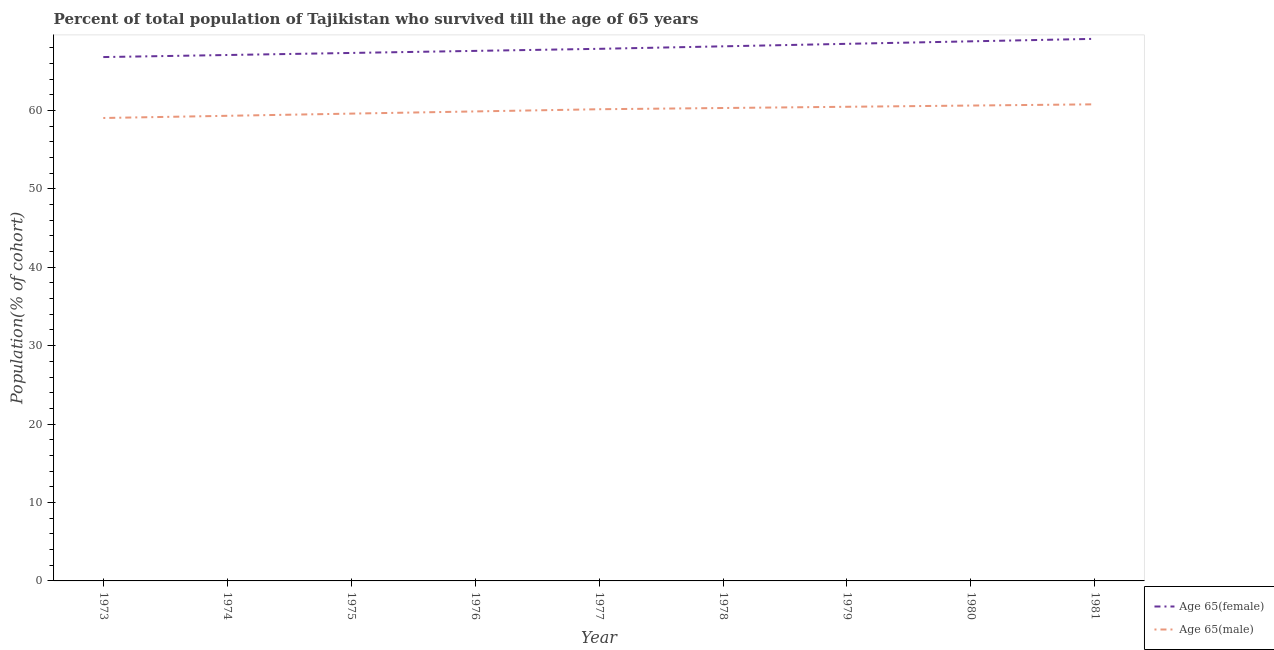Does the line corresponding to percentage of female population who survived till age of 65 intersect with the line corresponding to percentage of male population who survived till age of 65?
Offer a very short reply. No. Is the number of lines equal to the number of legend labels?
Keep it short and to the point. Yes. What is the percentage of male population who survived till age of 65 in 1974?
Provide a short and direct response. 59.31. Across all years, what is the maximum percentage of female population who survived till age of 65?
Your answer should be very brief. 69.12. Across all years, what is the minimum percentage of male population who survived till age of 65?
Provide a short and direct response. 59.03. What is the total percentage of female population who survived till age of 65 in the graph?
Provide a short and direct response. 611.19. What is the difference between the percentage of male population who survived till age of 65 in 1975 and that in 1976?
Your response must be concise. -0.28. What is the difference between the percentage of male population who survived till age of 65 in 1974 and the percentage of female population who survived till age of 65 in 1976?
Offer a very short reply. -8.28. What is the average percentage of male population who survived till age of 65 per year?
Ensure brevity in your answer.  60.01. In the year 1980, what is the difference between the percentage of female population who survived till age of 65 and percentage of male population who survived till age of 65?
Provide a short and direct response. 8.19. In how many years, is the percentage of male population who survived till age of 65 greater than 14 %?
Give a very brief answer. 9. What is the ratio of the percentage of female population who survived till age of 65 in 1976 to that in 1977?
Keep it short and to the point. 1. Is the percentage of female population who survived till age of 65 in 1978 less than that in 1981?
Ensure brevity in your answer.  Yes. Is the difference between the percentage of female population who survived till age of 65 in 1974 and 1979 greater than the difference between the percentage of male population who survived till age of 65 in 1974 and 1979?
Make the answer very short. No. What is the difference between the highest and the second highest percentage of male population who survived till age of 65?
Keep it short and to the point. 0.16. What is the difference between the highest and the lowest percentage of female population who survived till age of 65?
Your response must be concise. 2.32. In how many years, is the percentage of female population who survived till age of 65 greater than the average percentage of female population who survived till age of 65 taken over all years?
Provide a short and direct response. 4. Does the percentage of female population who survived till age of 65 monotonically increase over the years?
Make the answer very short. Yes. Is the percentage of male population who survived till age of 65 strictly greater than the percentage of female population who survived till age of 65 over the years?
Give a very brief answer. No. Is the percentage of male population who survived till age of 65 strictly less than the percentage of female population who survived till age of 65 over the years?
Provide a succinct answer. Yes. How many lines are there?
Provide a succinct answer. 2. What is the difference between two consecutive major ticks on the Y-axis?
Provide a short and direct response. 10. Are the values on the major ticks of Y-axis written in scientific E-notation?
Keep it short and to the point. No. Does the graph contain any zero values?
Offer a terse response. No. How many legend labels are there?
Ensure brevity in your answer.  2. How are the legend labels stacked?
Give a very brief answer. Vertical. What is the title of the graph?
Your response must be concise. Percent of total population of Tajikistan who survived till the age of 65 years. Does "Electricity and heat production" appear as one of the legend labels in the graph?
Offer a very short reply. No. What is the label or title of the Y-axis?
Offer a terse response. Population(% of cohort). What is the Population(% of cohort) in Age 65(female) in 1973?
Offer a very short reply. 66.8. What is the Population(% of cohort) in Age 65(male) in 1973?
Give a very brief answer. 59.03. What is the Population(% of cohort) of Age 65(female) in 1974?
Make the answer very short. 67.06. What is the Population(% of cohort) in Age 65(male) in 1974?
Ensure brevity in your answer.  59.31. What is the Population(% of cohort) of Age 65(female) in 1975?
Keep it short and to the point. 67.32. What is the Population(% of cohort) of Age 65(male) in 1975?
Provide a succinct answer. 59.59. What is the Population(% of cohort) of Age 65(female) in 1976?
Ensure brevity in your answer.  67.59. What is the Population(% of cohort) of Age 65(male) in 1976?
Your response must be concise. 59.87. What is the Population(% of cohort) in Age 65(female) in 1977?
Ensure brevity in your answer.  67.85. What is the Population(% of cohort) of Age 65(male) in 1977?
Offer a terse response. 60.15. What is the Population(% of cohort) of Age 65(female) in 1978?
Your response must be concise. 68.17. What is the Population(% of cohort) in Age 65(male) in 1978?
Provide a succinct answer. 60.3. What is the Population(% of cohort) in Age 65(female) in 1979?
Provide a succinct answer. 68.49. What is the Population(% of cohort) in Age 65(male) in 1979?
Make the answer very short. 60.46. What is the Population(% of cohort) in Age 65(female) in 1980?
Offer a terse response. 68.8. What is the Population(% of cohort) in Age 65(male) in 1980?
Give a very brief answer. 60.62. What is the Population(% of cohort) in Age 65(female) in 1981?
Your response must be concise. 69.12. What is the Population(% of cohort) in Age 65(male) in 1981?
Offer a very short reply. 60.77. Across all years, what is the maximum Population(% of cohort) of Age 65(female)?
Keep it short and to the point. 69.12. Across all years, what is the maximum Population(% of cohort) of Age 65(male)?
Provide a short and direct response. 60.77. Across all years, what is the minimum Population(% of cohort) of Age 65(female)?
Offer a very short reply. 66.8. Across all years, what is the minimum Population(% of cohort) in Age 65(male)?
Give a very brief answer. 59.03. What is the total Population(% of cohort) in Age 65(female) in the graph?
Offer a very short reply. 611.19. What is the total Population(% of cohort) of Age 65(male) in the graph?
Offer a terse response. 540.08. What is the difference between the Population(% of cohort) of Age 65(female) in 1973 and that in 1974?
Your response must be concise. -0.26. What is the difference between the Population(% of cohort) in Age 65(male) in 1973 and that in 1974?
Your answer should be very brief. -0.28. What is the difference between the Population(% of cohort) in Age 65(female) in 1973 and that in 1975?
Your response must be concise. -0.53. What is the difference between the Population(% of cohort) of Age 65(male) in 1973 and that in 1975?
Your answer should be compact. -0.56. What is the difference between the Population(% of cohort) in Age 65(female) in 1973 and that in 1976?
Your answer should be compact. -0.79. What is the difference between the Population(% of cohort) of Age 65(male) in 1973 and that in 1976?
Offer a terse response. -0.84. What is the difference between the Population(% of cohort) of Age 65(female) in 1973 and that in 1977?
Provide a succinct answer. -1.05. What is the difference between the Population(% of cohort) in Age 65(male) in 1973 and that in 1977?
Ensure brevity in your answer.  -1.12. What is the difference between the Population(% of cohort) in Age 65(female) in 1973 and that in 1978?
Provide a short and direct response. -1.37. What is the difference between the Population(% of cohort) of Age 65(male) in 1973 and that in 1978?
Your answer should be very brief. -1.27. What is the difference between the Population(% of cohort) in Age 65(female) in 1973 and that in 1979?
Provide a short and direct response. -1.69. What is the difference between the Population(% of cohort) of Age 65(male) in 1973 and that in 1979?
Your answer should be compact. -1.43. What is the difference between the Population(% of cohort) of Age 65(female) in 1973 and that in 1980?
Offer a very short reply. -2.01. What is the difference between the Population(% of cohort) in Age 65(male) in 1973 and that in 1980?
Offer a very short reply. -1.59. What is the difference between the Population(% of cohort) of Age 65(female) in 1973 and that in 1981?
Give a very brief answer. -2.32. What is the difference between the Population(% of cohort) in Age 65(male) in 1973 and that in 1981?
Provide a short and direct response. -1.74. What is the difference between the Population(% of cohort) in Age 65(female) in 1974 and that in 1975?
Give a very brief answer. -0.26. What is the difference between the Population(% of cohort) of Age 65(male) in 1974 and that in 1975?
Provide a short and direct response. -0.28. What is the difference between the Population(% of cohort) of Age 65(female) in 1974 and that in 1976?
Your response must be concise. -0.53. What is the difference between the Population(% of cohort) in Age 65(male) in 1974 and that in 1976?
Offer a very short reply. -0.56. What is the difference between the Population(% of cohort) of Age 65(female) in 1974 and that in 1977?
Keep it short and to the point. -0.79. What is the difference between the Population(% of cohort) in Age 65(male) in 1974 and that in 1977?
Your response must be concise. -0.84. What is the difference between the Population(% of cohort) of Age 65(female) in 1974 and that in 1978?
Provide a succinct answer. -1.11. What is the difference between the Population(% of cohort) of Age 65(male) in 1974 and that in 1978?
Your answer should be compact. -0.99. What is the difference between the Population(% of cohort) of Age 65(female) in 1974 and that in 1979?
Your answer should be very brief. -1.43. What is the difference between the Population(% of cohort) of Age 65(male) in 1974 and that in 1979?
Your answer should be compact. -1.15. What is the difference between the Population(% of cohort) in Age 65(female) in 1974 and that in 1980?
Provide a short and direct response. -1.74. What is the difference between the Population(% of cohort) in Age 65(male) in 1974 and that in 1980?
Provide a short and direct response. -1.31. What is the difference between the Population(% of cohort) of Age 65(female) in 1974 and that in 1981?
Offer a very short reply. -2.06. What is the difference between the Population(% of cohort) in Age 65(male) in 1974 and that in 1981?
Your response must be concise. -1.46. What is the difference between the Population(% of cohort) of Age 65(female) in 1975 and that in 1976?
Offer a terse response. -0.26. What is the difference between the Population(% of cohort) of Age 65(male) in 1975 and that in 1976?
Your response must be concise. -0.28. What is the difference between the Population(% of cohort) in Age 65(female) in 1975 and that in 1977?
Provide a short and direct response. -0.53. What is the difference between the Population(% of cohort) of Age 65(male) in 1975 and that in 1977?
Your answer should be very brief. -0.56. What is the difference between the Population(% of cohort) in Age 65(female) in 1975 and that in 1978?
Your response must be concise. -0.84. What is the difference between the Population(% of cohort) in Age 65(male) in 1975 and that in 1978?
Make the answer very short. -0.71. What is the difference between the Population(% of cohort) in Age 65(female) in 1975 and that in 1979?
Provide a short and direct response. -1.16. What is the difference between the Population(% of cohort) in Age 65(male) in 1975 and that in 1979?
Offer a terse response. -0.87. What is the difference between the Population(% of cohort) of Age 65(female) in 1975 and that in 1980?
Provide a short and direct response. -1.48. What is the difference between the Population(% of cohort) in Age 65(male) in 1975 and that in 1980?
Ensure brevity in your answer.  -1.03. What is the difference between the Population(% of cohort) in Age 65(female) in 1975 and that in 1981?
Provide a succinct answer. -1.8. What is the difference between the Population(% of cohort) in Age 65(male) in 1975 and that in 1981?
Provide a short and direct response. -1.19. What is the difference between the Population(% of cohort) of Age 65(female) in 1976 and that in 1977?
Make the answer very short. -0.26. What is the difference between the Population(% of cohort) in Age 65(male) in 1976 and that in 1977?
Your answer should be compact. -0.28. What is the difference between the Population(% of cohort) in Age 65(female) in 1976 and that in 1978?
Make the answer very short. -0.58. What is the difference between the Population(% of cohort) of Age 65(male) in 1976 and that in 1978?
Ensure brevity in your answer.  -0.44. What is the difference between the Population(% of cohort) of Age 65(female) in 1976 and that in 1979?
Provide a short and direct response. -0.9. What is the difference between the Population(% of cohort) in Age 65(male) in 1976 and that in 1979?
Ensure brevity in your answer.  -0.59. What is the difference between the Population(% of cohort) of Age 65(female) in 1976 and that in 1980?
Offer a very short reply. -1.22. What is the difference between the Population(% of cohort) in Age 65(male) in 1976 and that in 1980?
Make the answer very short. -0.75. What is the difference between the Population(% of cohort) of Age 65(female) in 1976 and that in 1981?
Provide a short and direct response. -1.54. What is the difference between the Population(% of cohort) in Age 65(male) in 1976 and that in 1981?
Offer a terse response. -0.91. What is the difference between the Population(% of cohort) of Age 65(female) in 1977 and that in 1978?
Your answer should be very brief. -0.32. What is the difference between the Population(% of cohort) in Age 65(male) in 1977 and that in 1978?
Make the answer very short. -0.16. What is the difference between the Population(% of cohort) in Age 65(female) in 1977 and that in 1979?
Your answer should be very brief. -0.64. What is the difference between the Population(% of cohort) of Age 65(male) in 1977 and that in 1979?
Provide a short and direct response. -0.31. What is the difference between the Population(% of cohort) in Age 65(female) in 1977 and that in 1980?
Give a very brief answer. -0.96. What is the difference between the Population(% of cohort) in Age 65(male) in 1977 and that in 1980?
Provide a short and direct response. -0.47. What is the difference between the Population(% of cohort) of Age 65(female) in 1977 and that in 1981?
Ensure brevity in your answer.  -1.27. What is the difference between the Population(% of cohort) in Age 65(male) in 1977 and that in 1981?
Make the answer very short. -0.63. What is the difference between the Population(% of cohort) in Age 65(female) in 1978 and that in 1979?
Keep it short and to the point. -0.32. What is the difference between the Population(% of cohort) in Age 65(male) in 1978 and that in 1979?
Provide a succinct answer. -0.16. What is the difference between the Population(% of cohort) in Age 65(female) in 1978 and that in 1980?
Provide a succinct answer. -0.64. What is the difference between the Population(% of cohort) of Age 65(male) in 1978 and that in 1980?
Offer a terse response. -0.31. What is the difference between the Population(% of cohort) in Age 65(female) in 1978 and that in 1981?
Provide a short and direct response. -0.96. What is the difference between the Population(% of cohort) of Age 65(male) in 1978 and that in 1981?
Offer a very short reply. -0.47. What is the difference between the Population(% of cohort) in Age 65(female) in 1979 and that in 1980?
Provide a short and direct response. -0.32. What is the difference between the Population(% of cohort) of Age 65(male) in 1979 and that in 1980?
Provide a succinct answer. -0.16. What is the difference between the Population(% of cohort) of Age 65(female) in 1979 and that in 1981?
Your answer should be compact. -0.64. What is the difference between the Population(% of cohort) in Age 65(male) in 1979 and that in 1981?
Your answer should be compact. -0.31. What is the difference between the Population(% of cohort) of Age 65(female) in 1980 and that in 1981?
Provide a succinct answer. -0.32. What is the difference between the Population(% of cohort) of Age 65(male) in 1980 and that in 1981?
Make the answer very short. -0.16. What is the difference between the Population(% of cohort) of Age 65(female) in 1973 and the Population(% of cohort) of Age 65(male) in 1974?
Offer a very short reply. 7.49. What is the difference between the Population(% of cohort) of Age 65(female) in 1973 and the Population(% of cohort) of Age 65(male) in 1975?
Offer a terse response. 7.21. What is the difference between the Population(% of cohort) in Age 65(female) in 1973 and the Population(% of cohort) in Age 65(male) in 1976?
Make the answer very short. 6.93. What is the difference between the Population(% of cohort) of Age 65(female) in 1973 and the Population(% of cohort) of Age 65(male) in 1977?
Your response must be concise. 6.65. What is the difference between the Population(% of cohort) in Age 65(female) in 1973 and the Population(% of cohort) in Age 65(male) in 1978?
Your answer should be very brief. 6.5. What is the difference between the Population(% of cohort) in Age 65(female) in 1973 and the Population(% of cohort) in Age 65(male) in 1979?
Offer a very short reply. 6.34. What is the difference between the Population(% of cohort) of Age 65(female) in 1973 and the Population(% of cohort) of Age 65(male) in 1980?
Ensure brevity in your answer.  6.18. What is the difference between the Population(% of cohort) of Age 65(female) in 1973 and the Population(% of cohort) of Age 65(male) in 1981?
Give a very brief answer. 6.03. What is the difference between the Population(% of cohort) in Age 65(female) in 1974 and the Population(% of cohort) in Age 65(male) in 1975?
Offer a very short reply. 7.47. What is the difference between the Population(% of cohort) of Age 65(female) in 1974 and the Population(% of cohort) of Age 65(male) in 1976?
Provide a succinct answer. 7.19. What is the difference between the Population(% of cohort) of Age 65(female) in 1974 and the Population(% of cohort) of Age 65(male) in 1977?
Ensure brevity in your answer.  6.92. What is the difference between the Population(% of cohort) in Age 65(female) in 1974 and the Population(% of cohort) in Age 65(male) in 1978?
Keep it short and to the point. 6.76. What is the difference between the Population(% of cohort) in Age 65(female) in 1974 and the Population(% of cohort) in Age 65(male) in 1979?
Offer a very short reply. 6.6. What is the difference between the Population(% of cohort) of Age 65(female) in 1974 and the Population(% of cohort) of Age 65(male) in 1980?
Provide a short and direct response. 6.45. What is the difference between the Population(% of cohort) of Age 65(female) in 1974 and the Population(% of cohort) of Age 65(male) in 1981?
Provide a short and direct response. 6.29. What is the difference between the Population(% of cohort) in Age 65(female) in 1975 and the Population(% of cohort) in Age 65(male) in 1976?
Your answer should be very brief. 7.46. What is the difference between the Population(% of cohort) in Age 65(female) in 1975 and the Population(% of cohort) in Age 65(male) in 1977?
Provide a short and direct response. 7.18. What is the difference between the Population(% of cohort) in Age 65(female) in 1975 and the Population(% of cohort) in Age 65(male) in 1978?
Keep it short and to the point. 7.02. What is the difference between the Population(% of cohort) of Age 65(female) in 1975 and the Population(% of cohort) of Age 65(male) in 1979?
Make the answer very short. 6.86. What is the difference between the Population(% of cohort) in Age 65(female) in 1975 and the Population(% of cohort) in Age 65(male) in 1980?
Give a very brief answer. 6.71. What is the difference between the Population(% of cohort) of Age 65(female) in 1975 and the Population(% of cohort) of Age 65(male) in 1981?
Your answer should be compact. 6.55. What is the difference between the Population(% of cohort) in Age 65(female) in 1976 and the Population(% of cohort) in Age 65(male) in 1977?
Ensure brevity in your answer.  7.44. What is the difference between the Population(% of cohort) of Age 65(female) in 1976 and the Population(% of cohort) of Age 65(male) in 1978?
Offer a terse response. 7.28. What is the difference between the Population(% of cohort) in Age 65(female) in 1976 and the Population(% of cohort) in Age 65(male) in 1979?
Your response must be concise. 7.13. What is the difference between the Population(% of cohort) in Age 65(female) in 1976 and the Population(% of cohort) in Age 65(male) in 1980?
Offer a very short reply. 6.97. What is the difference between the Population(% of cohort) of Age 65(female) in 1976 and the Population(% of cohort) of Age 65(male) in 1981?
Provide a short and direct response. 6.81. What is the difference between the Population(% of cohort) of Age 65(female) in 1977 and the Population(% of cohort) of Age 65(male) in 1978?
Your answer should be very brief. 7.55. What is the difference between the Population(% of cohort) in Age 65(female) in 1977 and the Population(% of cohort) in Age 65(male) in 1979?
Provide a short and direct response. 7.39. What is the difference between the Population(% of cohort) in Age 65(female) in 1977 and the Population(% of cohort) in Age 65(male) in 1980?
Your response must be concise. 7.23. What is the difference between the Population(% of cohort) of Age 65(female) in 1977 and the Population(% of cohort) of Age 65(male) in 1981?
Offer a very short reply. 7.08. What is the difference between the Population(% of cohort) of Age 65(female) in 1978 and the Population(% of cohort) of Age 65(male) in 1979?
Provide a short and direct response. 7.71. What is the difference between the Population(% of cohort) of Age 65(female) in 1978 and the Population(% of cohort) of Age 65(male) in 1980?
Make the answer very short. 7.55. What is the difference between the Population(% of cohort) of Age 65(female) in 1978 and the Population(% of cohort) of Age 65(male) in 1981?
Ensure brevity in your answer.  7.39. What is the difference between the Population(% of cohort) in Age 65(female) in 1979 and the Population(% of cohort) in Age 65(male) in 1980?
Provide a succinct answer. 7.87. What is the difference between the Population(% of cohort) in Age 65(female) in 1979 and the Population(% of cohort) in Age 65(male) in 1981?
Provide a succinct answer. 7.71. What is the difference between the Population(% of cohort) of Age 65(female) in 1980 and the Population(% of cohort) of Age 65(male) in 1981?
Make the answer very short. 8.03. What is the average Population(% of cohort) in Age 65(female) per year?
Provide a succinct answer. 67.91. What is the average Population(% of cohort) in Age 65(male) per year?
Give a very brief answer. 60.01. In the year 1973, what is the difference between the Population(% of cohort) of Age 65(female) and Population(% of cohort) of Age 65(male)?
Offer a terse response. 7.77. In the year 1974, what is the difference between the Population(% of cohort) of Age 65(female) and Population(% of cohort) of Age 65(male)?
Offer a terse response. 7.75. In the year 1975, what is the difference between the Population(% of cohort) in Age 65(female) and Population(% of cohort) in Age 65(male)?
Offer a very short reply. 7.74. In the year 1976, what is the difference between the Population(% of cohort) in Age 65(female) and Population(% of cohort) in Age 65(male)?
Keep it short and to the point. 7.72. In the year 1977, what is the difference between the Population(% of cohort) in Age 65(female) and Population(% of cohort) in Age 65(male)?
Ensure brevity in your answer.  7.7. In the year 1978, what is the difference between the Population(% of cohort) in Age 65(female) and Population(% of cohort) in Age 65(male)?
Provide a succinct answer. 7.87. In the year 1979, what is the difference between the Population(% of cohort) of Age 65(female) and Population(% of cohort) of Age 65(male)?
Offer a terse response. 8.03. In the year 1980, what is the difference between the Population(% of cohort) of Age 65(female) and Population(% of cohort) of Age 65(male)?
Offer a very short reply. 8.19. In the year 1981, what is the difference between the Population(% of cohort) in Age 65(female) and Population(% of cohort) in Age 65(male)?
Provide a succinct answer. 8.35. What is the ratio of the Population(% of cohort) in Age 65(female) in 1973 to that in 1974?
Keep it short and to the point. 1. What is the ratio of the Population(% of cohort) in Age 65(male) in 1973 to that in 1975?
Provide a succinct answer. 0.99. What is the ratio of the Population(% of cohort) of Age 65(female) in 1973 to that in 1976?
Your response must be concise. 0.99. What is the ratio of the Population(% of cohort) of Age 65(female) in 1973 to that in 1977?
Give a very brief answer. 0.98. What is the ratio of the Population(% of cohort) of Age 65(male) in 1973 to that in 1977?
Ensure brevity in your answer.  0.98. What is the ratio of the Population(% of cohort) of Age 65(female) in 1973 to that in 1978?
Ensure brevity in your answer.  0.98. What is the ratio of the Population(% of cohort) of Age 65(male) in 1973 to that in 1978?
Your answer should be compact. 0.98. What is the ratio of the Population(% of cohort) in Age 65(female) in 1973 to that in 1979?
Provide a succinct answer. 0.98. What is the ratio of the Population(% of cohort) in Age 65(male) in 1973 to that in 1979?
Your response must be concise. 0.98. What is the ratio of the Population(% of cohort) of Age 65(female) in 1973 to that in 1980?
Ensure brevity in your answer.  0.97. What is the ratio of the Population(% of cohort) of Age 65(male) in 1973 to that in 1980?
Keep it short and to the point. 0.97. What is the ratio of the Population(% of cohort) of Age 65(female) in 1973 to that in 1981?
Your response must be concise. 0.97. What is the ratio of the Population(% of cohort) in Age 65(male) in 1973 to that in 1981?
Provide a short and direct response. 0.97. What is the ratio of the Population(% of cohort) in Age 65(male) in 1974 to that in 1975?
Ensure brevity in your answer.  1. What is the ratio of the Population(% of cohort) of Age 65(female) in 1974 to that in 1977?
Offer a terse response. 0.99. What is the ratio of the Population(% of cohort) of Age 65(male) in 1974 to that in 1977?
Make the answer very short. 0.99. What is the ratio of the Population(% of cohort) in Age 65(female) in 1974 to that in 1978?
Offer a very short reply. 0.98. What is the ratio of the Population(% of cohort) in Age 65(male) in 1974 to that in 1978?
Offer a very short reply. 0.98. What is the ratio of the Population(% of cohort) in Age 65(female) in 1974 to that in 1979?
Provide a succinct answer. 0.98. What is the ratio of the Population(% of cohort) in Age 65(male) in 1974 to that in 1979?
Provide a short and direct response. 0.98. What is the ratio of the Population(% of cohort) of Age 65(female) in 1974 to that in 1980?
Provide a succinct answer. 0.97. What is the ratio of the Population(% of cohort) of Age 65(male) in 1974 to that in 1980?
Keep it short and to the point. 0.98. What is the ratio of the Population(% of cohort) of Age 65(female) in 1974 to that in 1981?
Make the answer very short. 0.97. What is the ratio of the Population(% of cohort) in Age 65(male) in 1974 to that in 1981?
Ensure brevity in your answer.  0.98. What is the ratio of the Population(% of cohort) of Age 65(male) in 1975 to that in 1976?
Provide a succinct answer. 1. What is the ratio of the Population(% of cohort) in Age 65(female) in 1975 to that in 1977?
Your response must be concise. 0.99. What is the ratio of the Population(% of cohort) in Age 65(male) in 1975 to that in 1977?
Your answer should be very brief. 0.99. What is the ratio of the Population(% of cohort) in Age 65(female) in 1975 to that in 1978?
Offer a terse response. 0.99. What is the ratio of the Population(% of cohort) in Age 65(male) in 1975 to that in 1978?
Your response must be concise. 0.99. What is the ratio of the Population(% of cohort) of Age 65(male) in 1975 to that in 1979?
Ensure brevity in your answer.  0.99. What is the ratio of the Population(% of cohort) in Age 65(female) in 1975 to that in 1980?
Provide a short and direct response. 0.98. What is the ratio of the Population(% of cohort) in Age 65(male) in 1975 to that in 1980?
Your answer should be very brief. 0.98. What is the ratio of the Population(% of cohort) of Age 65(female) in 1975 to that in 1981?
Your answer should be compact. 0.97. What is the ratio of the Population(% of cohort) in Age 65(male) in 1975 to that in 1981?
Ensure brevity in your answer.  0.98. What is the ratio of the Population(% of cohort) in Age 65(female) in 1976 to that in 1979?
Ensure brevity in your answer.  0.99. What is the ratio of the Population(% of cohort) in Age 65(male) in 1976 to that in 1979?
Your response must be concise. 0.99. What is the ratio of the Population(% of cohort) in Age 65(female) in 1976 to that in 1980?
Your response must be concise. 0.98. What is the ratio of the Population(% of cohort) in Age 65(male) in 1976 to that in 1980?
Provide a succinct answer. 0.99. What is the ratio of the Population(% of cohort) of Age 65(female) in 1976 to that in 1981?
Make the answer very short. 0.98. What is the ratio of the Population(% of cohort) of Age 65(male) in 1976 to that in 1981?
Keep it short and to the point. 0.99. What is the ratio of the Population(% of cohort) in Age 65(male) in 1977 to that in 1978?
Ensure brevity in your answer.  1. What is the ratio of the Population(% of cohort) in Age 65(female) in 1977 to that in 1980?
Make the answer very short. 0.99. What is the ratio of the Population(% of cohort) in Age 65(male) in 1977 to that in 1980?
Give a very brief answer. 0.99. What is the ratio of the Population(% of cohort) in Age 65(female) in 1977 to that in 1981?
Provide a succinct answer. 0.98. What is the ratio of the Population(% of cohort) in Age 65(male) in 1977 to that in 1981?
Your answer should be very brief. 0.99. What is the ratio of the Population(% of cohort) in Age 65(male) in 1978 to that in 1979?
Your answer should be compact. 1. What is the ratio of the Population(% of cohort) of Age 65(female) in 1978 to that in 1981?
Offer a terse response. 0.99. What is the ratio of the Population(% of cohort) in Age 65(male) in 1978 to that in 1981?
Ensure brevity in your answer.  0.99. What is the ratio of the Population(% of cohort) in Age 65(female) in 1979 to that in 1980?
Ensure brevity in your answer.  1. What is the ratio of the Population(% of cohort) of Age 65(female) in 1980 to that in 1981?
Offer a terse response. 1. What is the difference between the highest and the second highest Population(% of cohort) in Age 65(female)?
Keep it short and to the point. 0.32. What is the difference between the highest and the second highest Population(% of cohort) of Age 65(male)?
Offer a very short reply. 0.16. What is the difference between the highest and the lowest Population(% of cohort) in Age 65(female)?
Offer a very short reply. 2.32. What is the difference between the highest and the lowest Population(% of cohort) in Age 65(male)?
Provide a short and direct response. 1.74. 